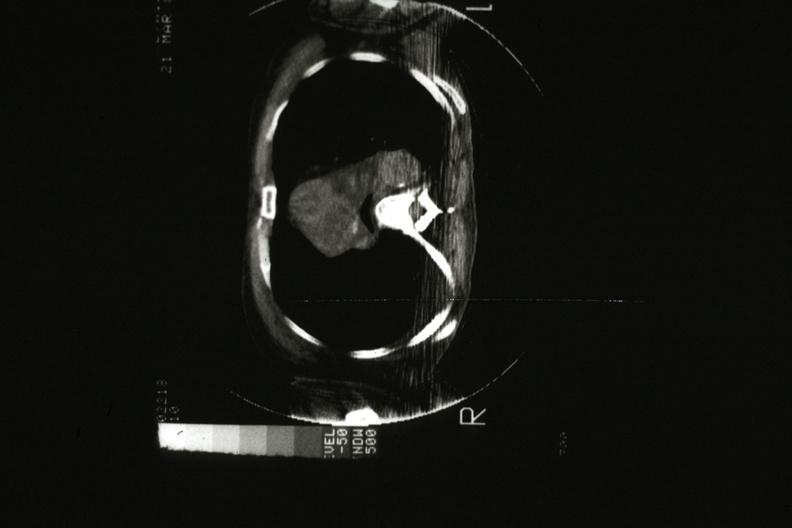does this image show cat scan showing tumor mass invading superior vena ca?
Answer the question using a single word or phrase. Yes 